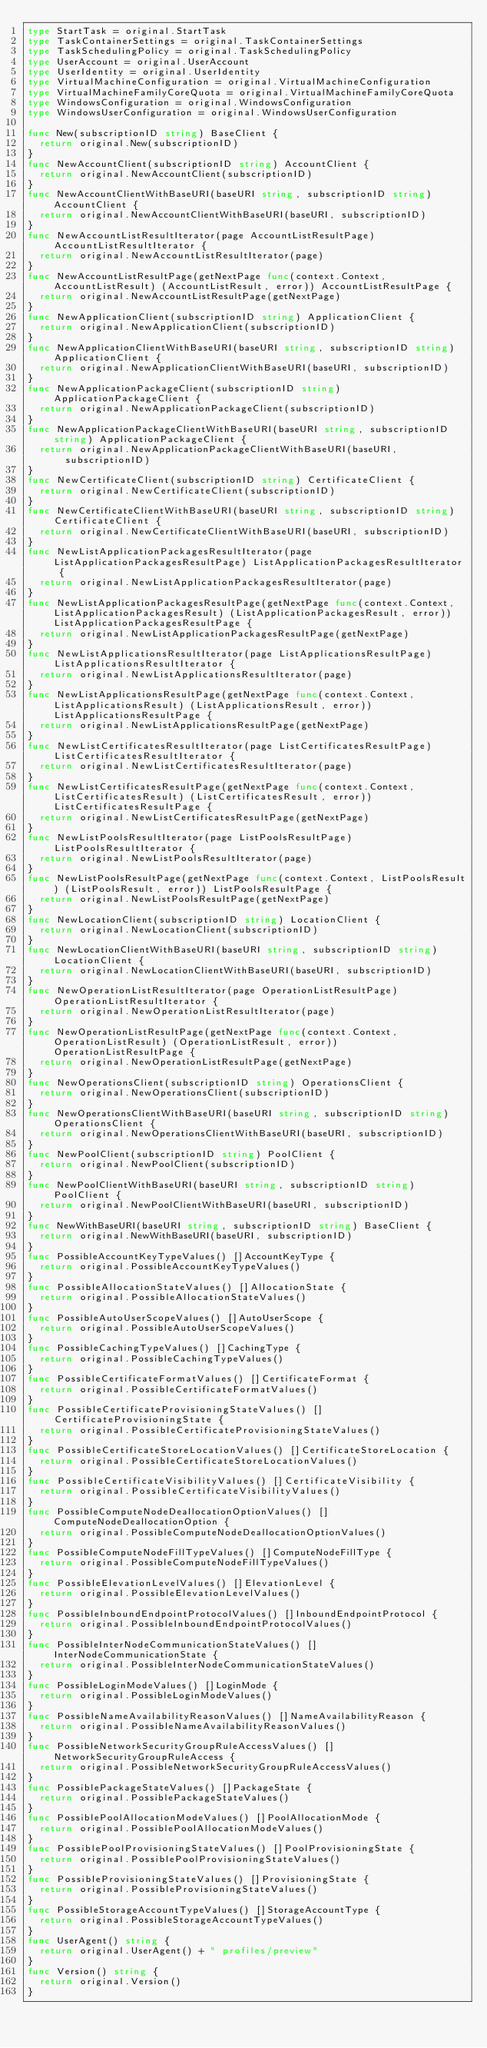<code> <loc_0><loc_0><loc_500><loc_500><_Go_>type StartTask = original.StartTask
type TaskContainerSettings = original.TaskContainerSettings
type TaskSchedulingPolicy = original.TaskSchedulingPolicy
type UserAccount = original.UserAccount
type UserIdentity = original.UserIdentity
type VirtualMachineConfiguration = original.VirtualMachineConfiguration
type VirtualMachineFamilyCoreQuota = original.VirtualMachineFamilyCoreQuota
type WindowsConfiguration = original.WindowsConfiguration
type WindowsUserConfiguration = original.WindowsUserConfiguration

func New(subscriptionID string) BaseClient {
	return original.New(subscriptionID)
}
func NewAccountClient(subscriptionID string) AccountClient {
	return original.NewAccountClient(subscriptionID)
}
func NewAccountClientWithBaseURI(baseURI string, subscriptionID string) AccountClient {
	return original.NewAccountClientWithBaseURI(baseURI, subscriptionID)
}
func NewAccountListResultIterator(page AccountListResultPage) AccountListResultIterator {
	return original.NewAccountListResultIterator(page)
}
func NewAccountListResultPage(getNextPage func(context.Context, AccountListResult) (AccountListResult, error)) AccountListResultPage {
	return original.NewAccountListResultPage(getNextPage)
}
func NewApplicationClient(subscriptionID string) ApplicationClient {
	return original.NewApplicationClient(subscriptionID)
}
func NewApplicationClientWithBaseURI(baseURI string, subscriptionID string) ApplicationClient {
	return original.NewApplicationClientWithBaseURI(baseURI, subscriptionID)
}
func NewApplicationPackageClient(subscriptionID string) ApplicationPackageClient {
	return original.NewApplicationPackageClient(subscriptionID)
}
func NewApplicationPackageClientWithBaseURI(baseURI string, subscriptionID string) ApplicationPackageClient {
	return original.NewApplicationPackageClientWithBaseURI(baseURI, subscriptionID)
}
func NewCertificateClient(subscriptionID string) CertificateClient {
	return original.NewCertificateClient(subscriptionID)
}
func NewCertificateClientWithBaseURI(baseURI string, subscriptionID string) CertificateClient {
	return original.NewCertificateClientWithBaseURI(baseURI, subscriptionID)
}
func NewListApplicationPackagesResultIterator(page ListApplicationPackagesResultPage) ListApplicationPackagesResultIterator {
	return original.NewListApplicationPackagesResultIterator(page)
}
func NewListApplicationPackagesResultPage(getNextPage func(context.Context, ListApplicationPackagesResult) (ListApplicationPackagesResult, error)) ListApplicationPackagesResultPage {
	return original.NewListApplicationPackagesResultPage(getNextPage)
}
func NewListApplicationsResultIterator(page ListApplicationsResultPage) ListApplicationsResultIterator {
	return original.NewListApplicationsResultIterator(page)
}
func NewListApplicationsResultPage(getNextPage func(context.Context, ListApplicationsResult) (ListApplicationsResult, error)) ListApplicationsResultPage {
	return original.NewListApplicationsResultPage(getNextPage)
}
func NewListCertificatesResultIterator(page ListCertificatesResultPage) ListCertificatesResultIterator {
	return original.NewListCertificatesResultIterator(page)
}
func NewListCertificatesResultPage(getNextPage func(context.Context, ListCertificatesResult) (ListCertificatesResult, error)) ListCertificatesResultPage {
	return original.NewListCertificatesResultPage(getNextPage)
}
func NewListPoolsResultIterator(page ListPoolsResultPage) ListPoolsResultIterator {
	return original.NewListPoolsResultIterator(page)
}
func NewListPoolsResultPage(getNextPage func(context.Context, ListPoolsResult) (ListPoolsResult, error)) ListPoolsResultPage {
	return original.NewListPoolsResultPage(getNextPage)
}
func NewLocationClient(subscriptionID string) LocationClient {
	return original.NewLocationClient(subscriptionID)
}
func NewLocationClientWithBaseURI(baseURI string, subscriptionID string) LocationClient {
	return original.NewLocationClientWithBaseURI(baseURI, subscriptionID)
}
func NewOperationListResultIterator(page OperationListResultPage) OperationListResultIterator {
	return original.NewOperationListResultIterator(page)
}
func NewOperationListResultPage(getNextPage func(context.Context, OperationListResult) (OperationListResult, error)) OperationListResultPage {
	return original.NewOperationListResultPage(getNextPage)
}
func NewOperationsClient(subscriptionID string) OperationsClient {
	return original.NewOperationsClient(subscriptionID)
}
func NewOperationsClientWithBaseURI(baseURI string, subscriptionID string) OperationsClient {
	return original.NewOperationsClientWithBaseURI(baseURI, subscriptionID)
}
func NewPoolClient(subscriptionID string) PoolClient {
	return original.NewPoolClient(subscriptionID)
}
func NewPoolClientWithBaseURI(baseURI string, subscriptionID string) PoolClient {
	return original.NewPoolClientWithBaseURI(baseURI, subscriptionID)
}
func NewWithBaseURI(baseURI string, subscriptionID string) BaseClient {
	return original.NewWithBaseURI(baseURI, subscriptionID)
}
func PossibleAccountKeyTypeValues() []AccountKeyType {
	return original.PossibleAccountKeyTypeValues()
}
func PossibleAllocationStateValues() []AllocationState {
	return original.PossibleAllocationStateValues()
}
func PossibleAutoUserScopeValues() []AutoUserScope {
	return original.PossibleAutoUserScopeValues()
}
func PossibleCachingTypeValues() []CachingType {
	return original.PossibleCachingTypeValues()
}
func PossibleCertificateFormatValues() []CertificateFormat {
	return original.PossibleCertificateFormatValues()
}
func PossibleCertificateProvisioningStateValues() []CertificateProvisioningState {
	return original.PossibleCertificateProvisioningStateValues()
}
func PossibleCertificateStoreLocationValues() []CertificateStoreLocation {
	return original.PossibleCertificateStoreLocationValues()
}
func PossibleCertificateVisibilityValues() []CertificateVisibility {
	return original.PossibleCertificateVisibilityValues()
}
func PossibleComputeNodeDeallocationOptionValues() []ComputeNodeDeallocationOption {
	return original.PossibleComputeNodeDeallocationOptionValues()
}
func PossibleComputeNodeFillTypeValues() []ComputeNodeFillType {
	return original.PossibleComputeNodeFillTypeValues()
}
func PossibleElevationLevelValues() []ElevationLevel {
	return original.PossibleElevationLevelValues()
}
func PossibleInboundEndpointProtocolValues() []InboundEndpointProtocol {
	return original.PossibleInboundEndpointProtocolValues()
}
func PossibleInterNodeCommunicationStateValues() []InterNodeCommunicationState {
	return original.PossibleInterNodeCommunicationStateValues()
}
func PossibleLoginModeValues() []LoginMode {
	return original.PossibleLoginModeValues()
}
func PossibleNameAvailabilityReasonValues() []NameAvailabilityReason {
	return original.PossibleNameAvailabilityReasonValues()
}
func PossibleNetworkSecurityGroupRuleAccessValues() []NetworkSecurityGroupRuleAccess {
	return original.PossibleNetworkSecurityGroupRuleAccessValues()
}
func PossiblePackageStateValues() []PackageState {
	return original.PossiblePackageStateValues()
}
func PossiblePoolAllocationModeValues() []PoolAllocationMode {
	return original.PossiblePoolAllocationModeValues()
}
func PossiblePoolProvisioningStateValues() []PoolProvisioningState {
	return original.PossiblePoolProvisioningStateValues()
}
func PossibleProvisioningStateValues() []ProvisioningState {
	return original.PossibleProvisioningStateValues()
}
func PossibleStorageAccountTypeValues() []StorageAccountType {
	return original.PossibleStorageAccountTypeValues()
}
func UserAgent() string {
	return original.UserAgent() + " profiles/preview"
}
func Version() string {
	return original.Version()
}
</code> 